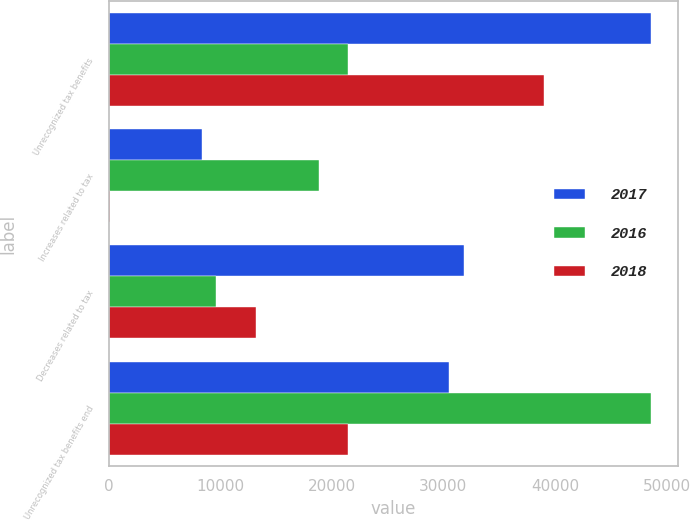Convert chart to OTSL. <chart><loc_0><loc_0><loc_500><loc_500><stacked_bar_chart><ecel><fcel>Unrecognized tax benefits<fcel>Increases related to tax<fcel>Decreases related to tax<fcel>Unrecognized tax benefits end<nl><fcel>2017<fcel>48604<fcel>8411<fcel>31850<fcel>30554<nl><fcel>2016<fcel>21502<fcel>18895<fcel>9665<fcel>48604<nl><fcel>2018<fcel>38992<fcel>114<fcel>13218<fcel>21502<nl></chart> 